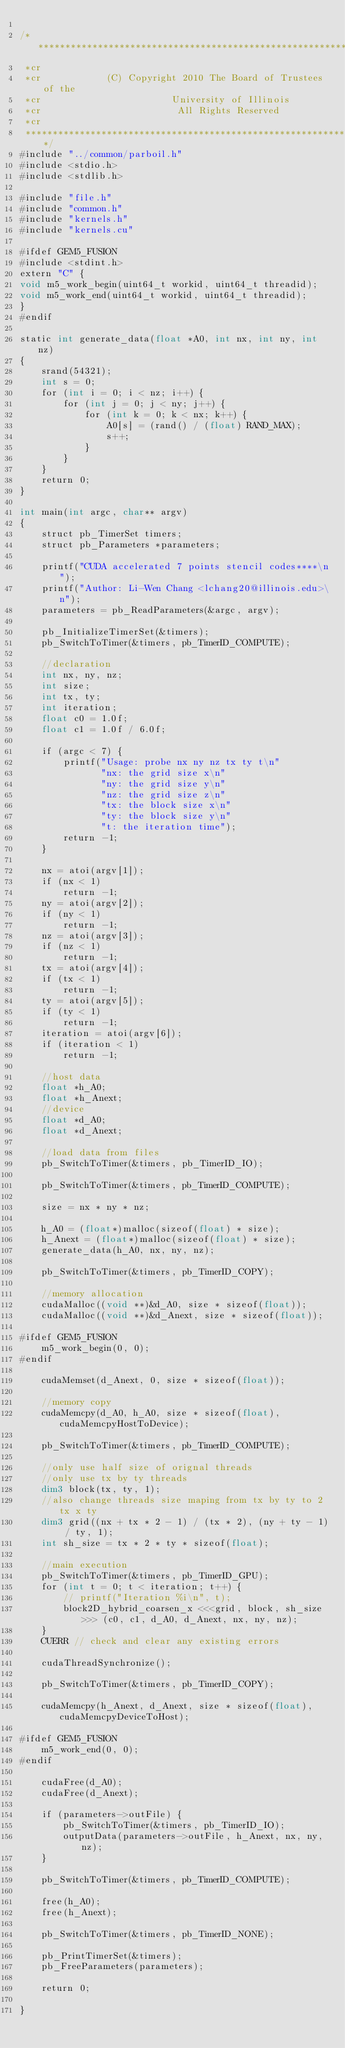<code> <loc_0><loc_0><loc_500><loc_500><_Cuda_>
/***************************************************************************
 *cr
 *cr            (C) Copyright 2010 The Board of Trustees of the
 *cr                        University of Illinois
 *cr                         All Rights Reserved
 *cr
 ***************************************************************************/
#include "../common/parboil.h"
#include <stdio.h>
#include <stdlib.h>

#include "file.h"
#include "common.h"
#include "kernels.h"
#include "kernels.cu"

#ifdef GEM5_FUSION
#include <stdint.h>
extern "C" {
void m5_work_begin(uint64_t workid, uint64_t threadid);
void m5_work_end(uint64_t workid, uint64_t threadid);
}
#endif

static int generate_data(float *A0, int nx, int ny, int nz)
{
    srand(54321);
    int s = 0;
    for (int i = 0; i < nz; i++) {
        for (int j = 0; j < ny; j++) {
            for (int k = 0; k < nx; k++) {
                A0[s] = (rand() / (float) RAND_MAX);
                s++;
            }
        }
    }
    return 0;
}

int main(int argc, char** argv)
{
    struct pb_TimerSet timers;
    struct pb_Parameters *parameters;

    printf("CUDA accelerated 7 points stencil codes****\n");
    printf("Author: Li-Wen Chang <lchang20@illinois.edu>\n");
    parameters = pb_ReadParameters(&argc, argv);

    pb_InitializeTimerSet(&timers);
    pb_SwitchToTimer(&timers, pb_TimerID_COMPUTE);

    //declaration
    int nx, ny, nz;
    int size;
    int tx, ty;
    int iteration;
    float c0 = 1.0f;
    float c1 = 1.0f / 6.0f;

    if (argc < 7) {
        printf("Usage: probe nx ny nz tx ty t\n"
               "nx: the grid size x\n"
               "ny: the grid size y\n"
               "nz: the grid size z\n"
               "tx: the block size x\n"
               "ty: the block size y\n"
               "t: the iteration time");
        return -1;
    }

    nx = atoi(argv[1]);
    if (nx < 1)
        return -1;
    ny = atoi(argv[2]);
    if (ny < 1)
        return -1;
    nz = atoi(argv[3]);
    if (nz < 1)
        return -1;
    tx = atoi(argv[4]);
    if (tx < 1)
        return -1;
    ty = atoi(argv[5]);
    if (ty < 1)
        return -1;
    iteration = atoi(argv[6]);
    if (iteration < 1)
        return -1;

    //host data
    float *h_A0;
    float *h_Anext;
    //device
    float *d_A0;
    float *d_Anext;

    //load data from files
    pb_SwitchToTimer(&timers, pb_TimerID_IO);

    pb_SwitchToTimer(&timers, pb_TimerID_COMPUTE);

    size = nx * ny * nz;

    h_A0 = (float*)malloc(sizeof(float) * size);
    h_Anext = (float*)malloc(sizeof(float) * size);
    generate_data(h_A0, nx, ny, nz);

    pb_SwitchToTimer(&timers, pb_TimerID_COPY);

    //memory allocation
    cudaMalloc((void **)&d_A0, size * sizeof(float));
    cudaMalloc((void **)&d_Anext, size * sizeof(float));

#ifdef GEM5_FUSION
    m5_work_begin(0, 0);
#endif

    cudaMemset(d_Anext, 0, size * sizeof(float));

    //memory copy
    cudaMemcpy(d_A0, h_A0, size * sizeof(float), cudaMemcpyHostToDevice);

    pb_SwitchToTimer(&timers, pb_TimerID_COMPUTE);

    //only use half size of orignal threads
    //only use tx by ty threads
    dim3 block(tx, ty, 1);
    //also change threads size maping from tx by ty to 2tx x ty
    dim3 grid((nx + tx * 2 - 1) / (tx * 2), (ny + ty - 1) / ty, 1);
    int sh_size = tx * 2 * ty * sizeof(float);

    //main execution
    pb_SwitchToTimer(&timers, pb_TimerID_GPU);
    for (int t = 0; t < iteration; t++) {
        // printf("Iteration %i\n", t);
        block2D_hybrid_coarsen_x <<<grid, block, sh_size>>> (c0, c1, d_A0, d_Anext, nx, ny, nz);
    }
    CUERR // check and clear any existing errors

    cudaThreadSynchronize();

    pb_SwitchToTimer(&timers, pb_TimerID_COPY);

    cudaMemcpy(h_Anext, d_Anext, size * sizeof(float), cudaMemcpyDeviceToHost);

#ifdef GEM5_FUSION
    m5_work_end(0, 0);
#endif

    cudaFree(d_A0);
    cudaFree(d_Anext);

    if (parameters->outFile) {
        pb_SwitchToTimer(&timers, pb_TimerID_IO);
        outputData(parameters->outFile, h_Anext, nx, ny, nz);
    }

    pb_SwitchToTimer(&timers, pb_TimerID_COMPUTE);

    free(h_A0);
    free(h_Anext);

    pb_SwitchToTimer(&timers, pb_TimerID_NONE);

    pb_PrintTimerSet(&timers);
    pb_FreeParameters(parameters);

    return 0;

}
</code> 